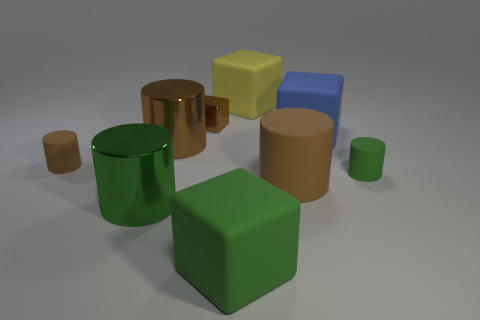Subtract all brown cylinders. How many were subtracted if there are1brown cylinders left? 2 Subtract all yellow cubes. How many cubes are left? 3 Subtract all cyan cubes. How many green cylinders are left? 2 Subtract 3 cylinders. How many cylinders are left? 2 Subtract all green cubes. How many cubes are left? 3 Add 1 large yellow matte blocks. How many objects exist? 10 Subtract all cyan blocks. Subtract all gray balls. How many blocks are left? 4 Subtract all blocks. How many objects are left? 5 Subtract all yellow objects. Subtract all brown things. How many objects are left? 4 Add 9 large matte cylinders. How many large matte cylinders are left? 10 